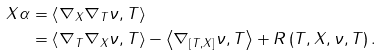Convert formula to latex. <formula><loc_0><loc_0><loc_500><loc_500>X \alpha & = \left \langle \nabla _ { X } \nabla _ { T } \nu , T \right \rangle \\ & = \left \langle \nabla _ { T } \nabla _ { X } \nu , T \right \rangle - \left \langle \nabla _ { \left [ T , X \right ] } \nu , T \right \rangle + R \left ( T , X , \nu , T \right ) .</formula> 